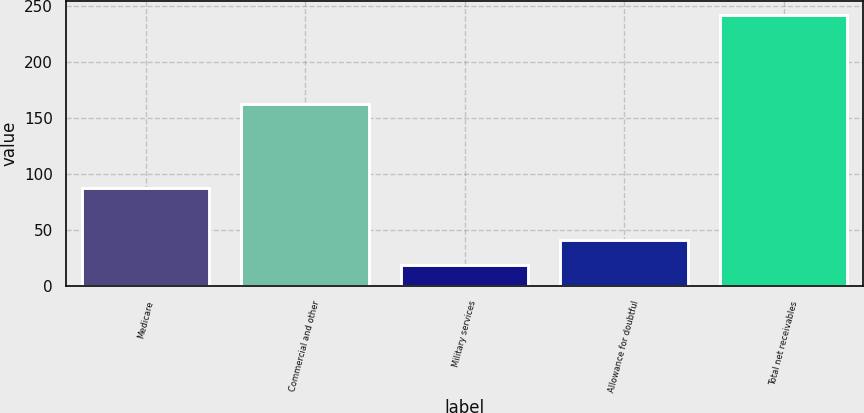Convert chart. <chart><loc_0><loc_0><loc_500><loc_500><bar_chart><fcel>Medicare<fcel>Commercial and other<fcel>Military services<fcel>Allowance for doubtful<fcel>Total net receivables<nl><fcel>88<fcel>162<fcel>19<fcel>41.3<fcel>242<nl></chart> 